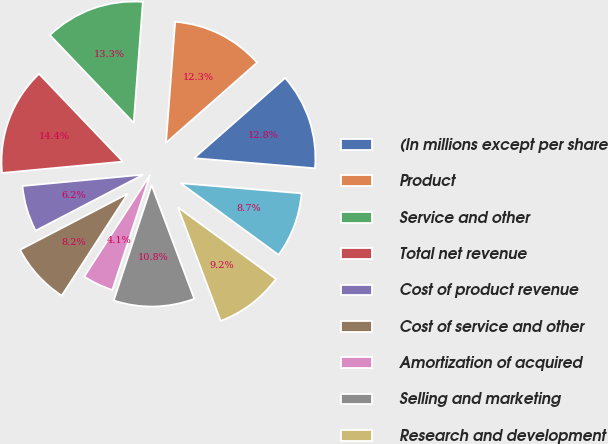Convert chart to OTSL. <chart><loc_0><loc_0><loc_500><loc_500><pie_chart><fcel>(In millions except per share<fcel>Product<fcel>Service and other<fcel>Total net revenue<fcel>Cost of product revenue<fcel>Cost of service and other<fcel>Amortization of acquired<fcel>Selling and marketing<fcel>Research and development<fcel>General and administrative<nl><fcel>12.82%<fcel>12.31%<fcel>13.33%<fcel>14.36%<fcel>6.15%<fcel>8.21%<fcel>4.1%<fcel>10.77%<fcel>9.23%<fcel>8.72%<nl></chart> 